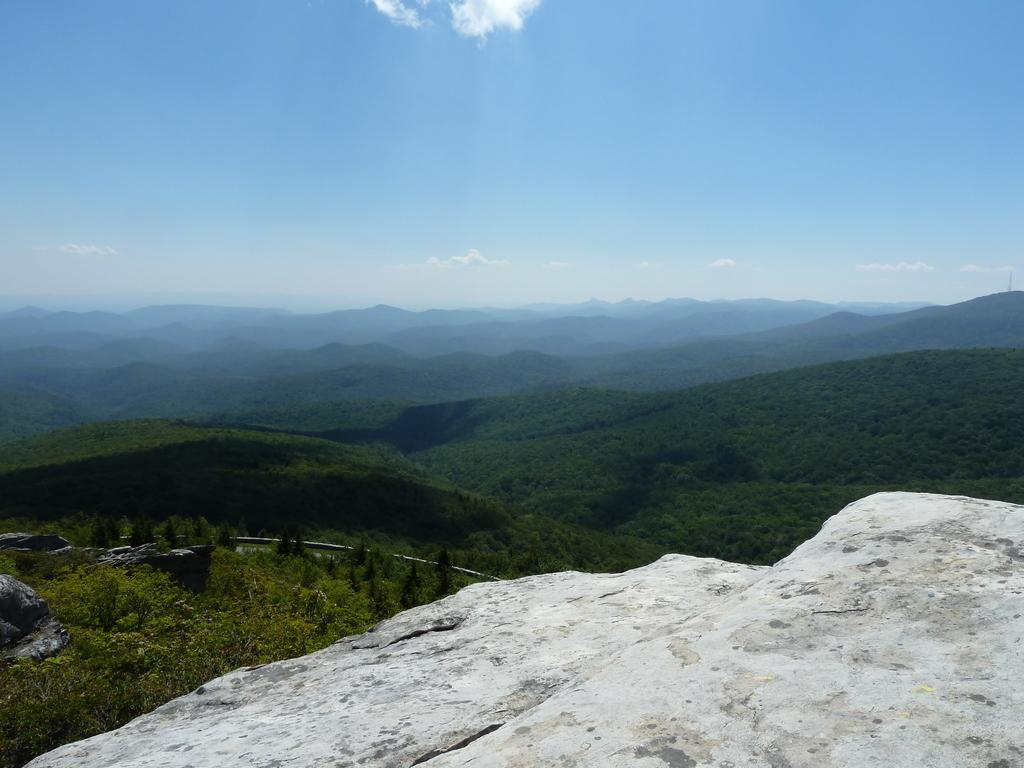What type of natural features can be seen in the front of the image? There are rocks in the front of the image. What other natural features are present in the image? There are trees and hills in the image. What is visible at the top of the image? The sky is visible at the top of the image. How many flowers are growing in the middle of the image? There are no flowers present in the image. What is the distance between the rocks and the trees in the image? The facts provided do not give information about the distance between the rocks and the trees, so it cannot be determined from the image. 